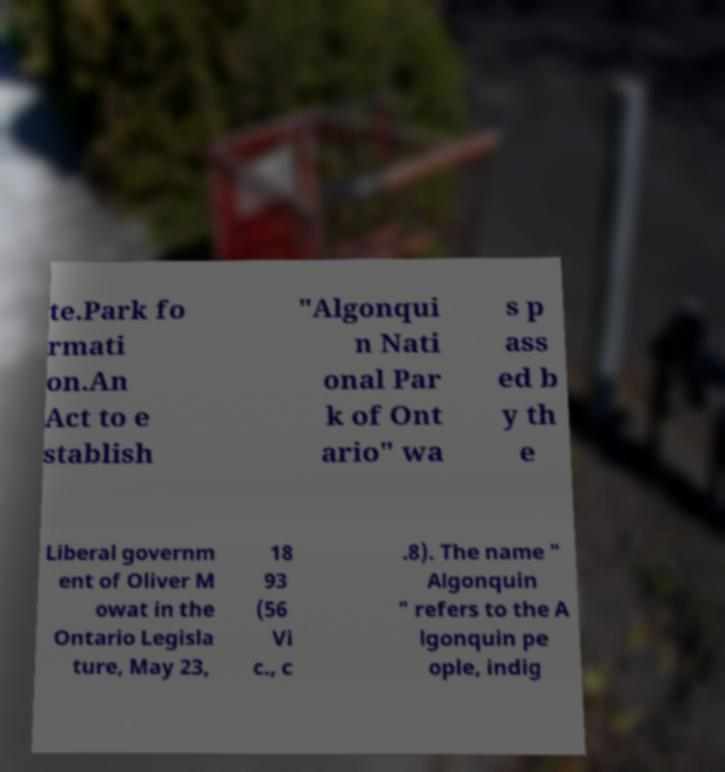Please identify and transcribe the text found in this image. te.Park fo rmati on.An Act to e stablish "Algonqui n Nati onal Par k of Ont ario" wa s p ass ed b y th e Liberal governm ent of Oliver M owat in the Ontario Legisla ture, May 23, 18 93 (56 Vi c., c .8). The name " Algonquin " refers to the A lgonquin pe ople, indig 